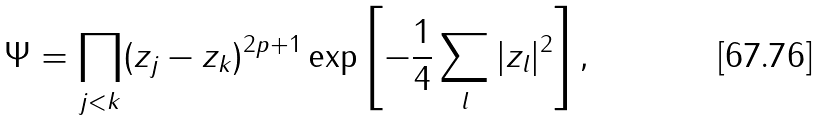Convert formula to latex. <formula><loc_0><loc_0><loc_500><loc_500>\Psi = \prod _ { j < k } ( z _ { j } - z _ { k } ) ^ { 2 p + 1 } \exp \left [ - \frac { 1 } { 4 } \sum _ { l } | z _ { l } | ^ { 2 } \right ] ,</formula> 